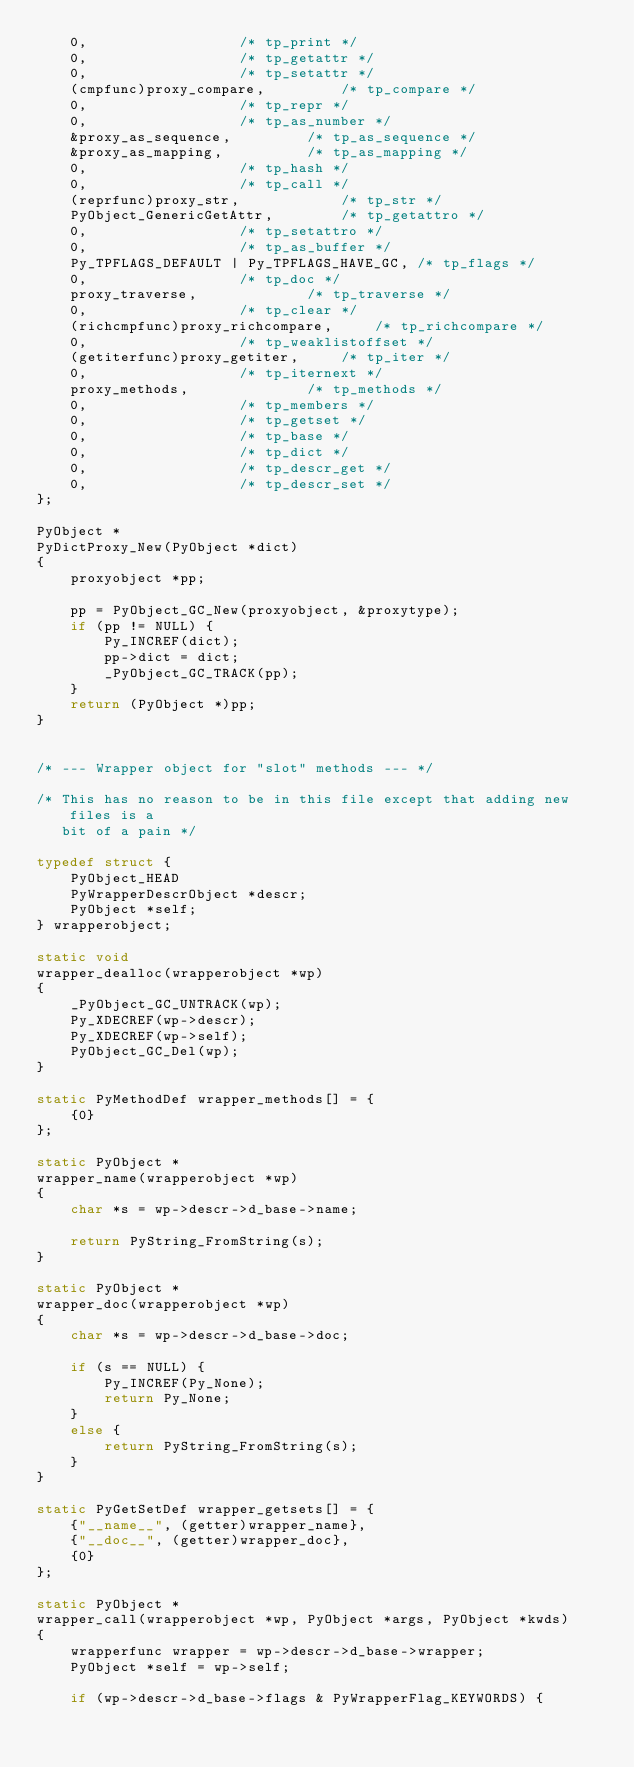<code> <loc_0><loc_0><loc_500><loc_500><_C_>	0,					/* tp_print */
	0,					/* tp_getattr */
	0,					/* tp_setattr */
	(cmpfunc)proxy_compare,			/* tp_compare */
	0,					/* tp_repr */
	0,					/* tp_as_number */
	&proxy_as_sequence,			/* tp_as_sequence */
	&proxy_as_mapping,			/* tp_as_mapping */
	0,					/* tp_hash */
	0,					/* tp_call */
	(reprfunc)proxy_str,			/* tp_str */
	PyObject_GenericGetAttr,		/* tp_getattro */
	0,					/* tp_setattro */
	0,					/* tp_as_buffer */
	Py_TPFLAGS_DEFAULT | Py_TPFLAGS_HAVE_GC, /* tp_flags */
 	0,					/* tp_doc */
	proxy_traverse,				/* tp_traverse */
 	0,					/* tp_clear */
	(richcmpfunc)proxy_richcompare,		/* tp_richcompare */
	0,					/* tp_weaklistoffset */
	(getiterfunc)proxy_getiter,		/* tp_iter */
	0,					/* tp_iternext */
	proxy_methods,				/* tp_methods */
	0,					/* tp_members */
	0,					/* tp_getset */
	0,					/* tp_base */
	0,					/* tp_dict */
	0,					/* tp_descr_get */
	0,					/* tp_descr_set */
};

PyObject *
PyDictProxy_New(PyObject *dict)
{
	proxyobject *pp;

	pp = PyObject_GC_New(proxyobject, &proxytype);
	if (pp != NULL) {
		Py_INCREF(dict);
		pp->dict = dict;
		_PyObject_GC_TRACK(pp);
	}
	return (PyObject *)pp;
}


/* --- Wrapper object for "slot" methods --- */

/* This has no reason to be in this file except that adding new files is a
   bit of a pain */

typedef struct {
	PyObject_HEAD
	PyWrapperDescrObject *descr;
	PyObject *self;
} wrapperobject;

static void
wrapper_dealloc(wrapperobject *wp)
{
	_PyObject_GC_UNTRACK(wp);
	Py_XDECREF(wp->descr);
	Py_XDECREF(wp->self);
	PyObject_GC_Del(wp);
}

static PyMethodDef wrapper_methods[] = {
	{0}
};

static PyObject *
wrapper_name(wrapperobject *wp)
{
	char *s = wp->descr->d_base->name;

	return PyString_FromString(s);
}

static PyObject *
wrapper_doc(wrapperobject *wp)
{
	char *s = wp->descr->d_base->doc;

	if (s == NULL) {
		Py_INCREF(Py_None);
		return Py_None;
	}
	else {
		return PyString_FromString(s);
	}
}

static PyGetSetDef wrapper_getsets[] = {
	{"__name__", (getter)wrapper_name},
	{"__doc__", (getter)wrapper_doc},
	{0}
};

static PyObject *
wrapper_call(wrapperobject *wp, PyObject *args, PyObject *kwds)
{
	wrapperfunc wrapper = wp->descr->d_base->wrapper;
	PyObject *self = wp->self;

	if (wp->descr->d_base->flags & PyWrapperFlag_KEYWORDS) {</code> 